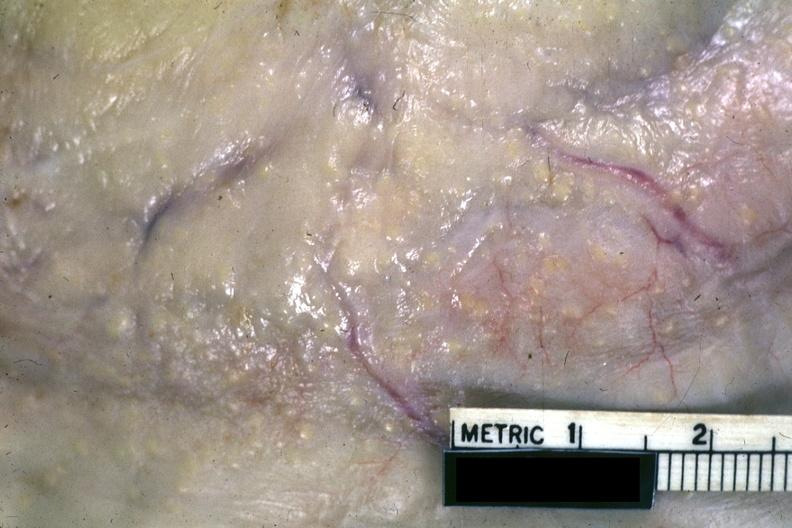what does this image show?
Answer the question using a single word or phrase. A very close-up view of typical gross lesions 